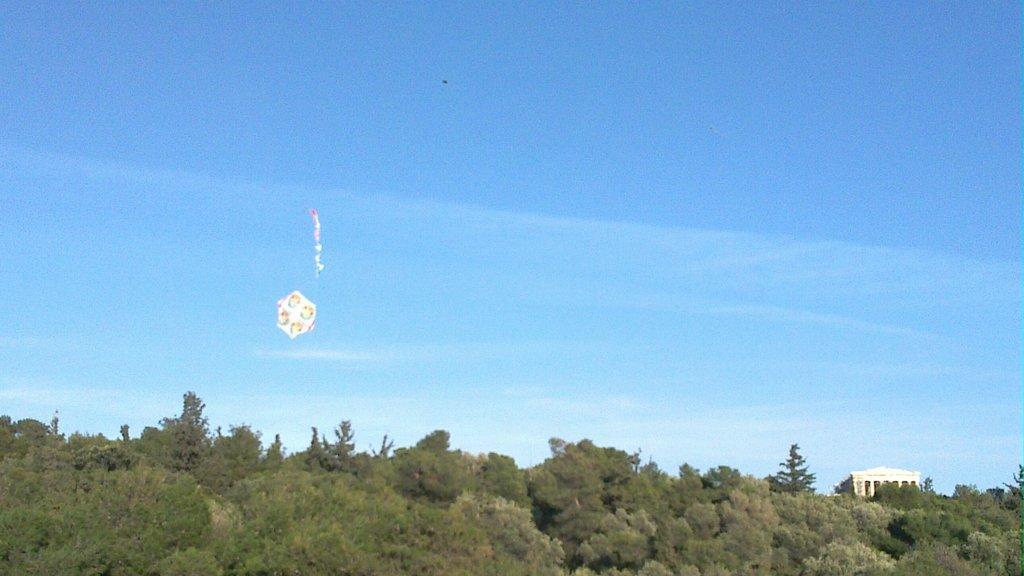Describe this image in one or two sentences. At the bottom of the image, we can see so many trees, house. Here we can see some object in the air. Background there is a sky. 